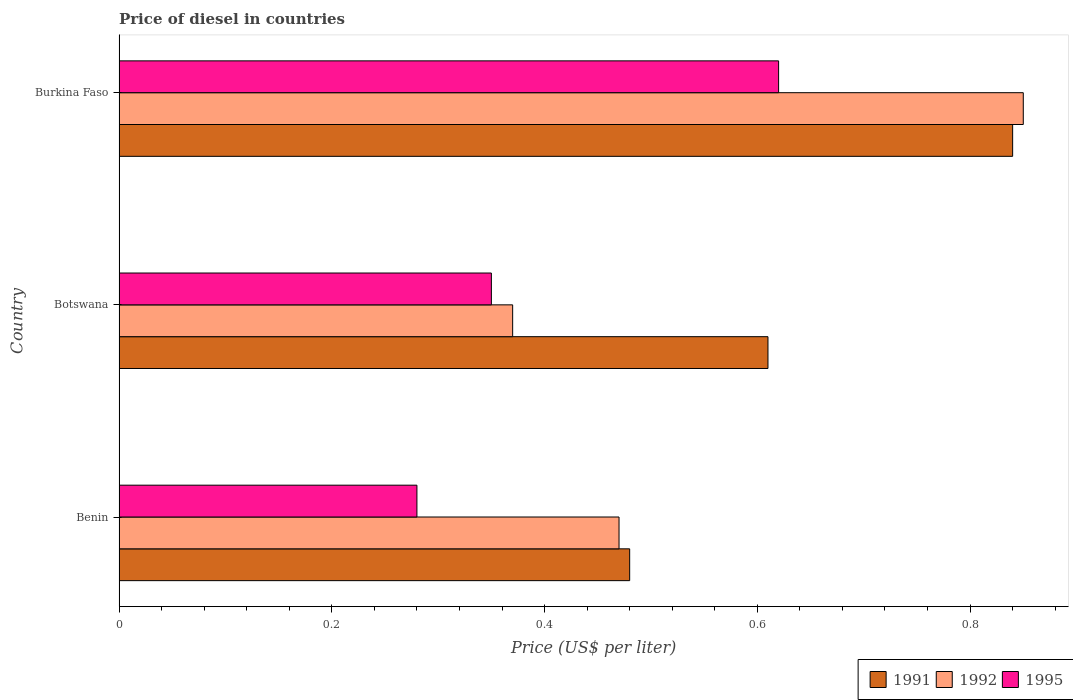How many different coloured bars are there?
Keep it short and to the point. 3. Are the number of bars per tick equal to the number of legend labels?
Offer a terse response. Yes. How many bars are there on the 2nd tick from the top?
Keep it short and to the point. 3. What is the label of the 1st group of bars from the top?
Offer a terse response. Burkina Faso. In how many cases, is the number of bars for a given country not equal to the number of legend labels?
Offer a very short reply. 0. What is the price of diesel in 1995 in Benin?
Provide a succinct answer. 0.28. Across all countries, what is the maximum price of diesel in 1991?
Your answer should be compact. 0.84. Across all countries, what is the minimum price of diesel in 1995?
Offer a very short reply. 0.28. In which country was the price of diesel in 1995 maximum?
Give a very brief answer. Burkina Faso. In which country was the price of diesel in 1995 minimum?
Make the answer very short. Benin. What is the total price of diesel in 1992 in the graph?
Provide a succinct answer. 1.69. What is the difference between the price of diesel in 1991 in Botswana and that in Burkina Faso?
Provide a succinct answer. -0.23. What is the difference between the price of diesel in 1995 in Benin and the price of diesel in 1992 in Botswana?
Provide a short and direct response. -0.09. What is the average price of diesel in 1992 per country?
Provide a short and direct response. 0.56. What is the difference between the price of diesel in 1992 and price of diesel in 1991 in Botswana?
Offer a terse response. -0.24. What is the ratio of the price of diesel in 1991 in Benin to that in Burkina Faso?
Keep it short and to the point. 0.57. What is the difference between the highest and the second highest price of diesel in 1995?
Ensure brevity in your answer.  0.27. What is the difference between the highest and the lowest price of diesel in 1995?
Provide a short and direct response. 0.34. In how many countries, is the price of diesel in 1995 greater than the average price of diesel in 1995 taken over all countries?
Make the answer very short. 1. Is the sum of the price of diesel in 1991 in Benin and Burkina Faso greater than the maximum price of diesel in 1995 across all countries?
Ensure brevity in your answer.  Yes. What does the 2nd bar from the top in Botswana represents?
Your response must be concise. 1992. Is it the case that in every country, the sum of the price of diesel in 1992 and price of diesel in 1991 is greater than the price of diesel in 1995?
Make the answer very short. Yes. What is the difference between two consecutive major ticks on the X-axis?
Your response must be concise. 0.2. How many legend labels are there?
Your answer should be very brief. 3. What is the title of the graph?
Offer a very short reply. Price of diesel in countries. What is the label or title of the X-axis?
Offer a terse response. Price (US$ per liter). What is the label or title of the Y-axis?
Ensure brevity in your answer.  Country. What is the Price (US$ per liter) of 1991 in Benin?
Ensure brevity in your answer.  0.48. What is the Price (US$ per liter) in 1992 in Benin?
Your answer should be compact. 0.47. What is the Price (US$ per liter) in 1995 in Benin?
Give a very brief answer. 0.28. What is the Price (US$ per liter) in 1991 in Botswana?
Provide a succinct answer. 0.61. What is the Price (US$ per liter) of 1992 in Botswana?
Keep it short and to the point. 0.37. What is the Price (US$ per liter) in 1991 in Burkina Faso?
Your answer should be compact. 0.84. What is the Price (US$ per liter) of 1995 in Burkina Faso?
Your answer should be compact. 0.62. Across all countries, what is the maximum Price (US$ per liter) in 1991?
Ensure brevity in your answer.  0.84. Across all countries, what is the maximum Price (US$ per liter) in 1992?
Your answer should be compact. 0.85. Across all countries, what is the maximum Price (US$ per liter) in 1995?
Make the answer very short. 0.62. Across all countries, what is the minimum Price (US$ per liter) of 1991?
Your response must be concise. 0.48. Across all countries, what is the minimum Price (US$ per liter) of 1992?
Make the answer very short. 0.37. Across all countries, what is the minimum Price (US$ per liter) in 1995?
Give a very brief answer. 0.28. What is the total Price (US$ per liter) of 1991 in the graph?
Ensure brevity in your answer.  1.93. What is the total Price (US$ per liter) of 1992 in the graph?
Give a very brief answer. 1.69. What is the difference between the Price (US$ per liter) of 1991 in Benin and that in Botswana?
Your response must be concise. -0.13. What is the difference between the Price (US$ per liter) of 1992 in Benin and that in Botswana?
Your answer should be very brief. 0.1. What is the difference between the Price (US$ per liter) in 1995 in Benin and that in Botswana?
Give a very brief answer. -0.07. What is the difference between the Price (US$ per liter) in 1991 in Benin and that in Burkina Faso?
Make the answer very short. -0.36. What is the difference between the Price (US$ per liter) of 1992 in Benin and that in Burkina Faso?
Provide a short and direct response. -0.38. What is the difference between the Price (US$ per liter) of 1995 in Benin and that in Burkina Faso?
Your answer should be very brief. -0.34. What is the difference between the Price (US$ per liter) of 1991 in Botswana and that in Burkina Faso?
Give a very brief answer. -0.23. What is the difference between the Price (US$ per liter) of 1992 in Botswana and that in Burkina Faso?
Offer a terse response. -0.48. What is the difference between the Price (US$ per liter) of 1995 in Botswana and that in Burkina Faso?
Your answer should be compact. -0.27. What is the difference between the Price (US$ per liter) of 1991 in Benin and the Price (US$ per liter) of 1992 in Botswana?
Offer a very short reply. 0.11. What is the difference between the Price (US$ per liter) in 1991 in Benin and the Price (US$ per liter) in 1995 in Botswana?
Keep it short and to the point. 0.13. What is the difference between the Price (US$ per liter) of 1992 in Benin and the Price (US$ per liter) of 1995 in Botswana?
Keep it short and to the point. 0.12. What is the difference between the Price (US$ per liter) in 1991 in Benin and the Price (US$ per liter) in 1992 in Burkina Faso?
Your answer should be very brief. -0.37. What is the difference between the Price (US$ per liter) of 1991 in Benin and the Price (US$ per liter) of 1995 in Burkina Faso?
Make the answer very short. -0.14. What is the difference between the Price (US$ per liter) of 1992 in Benin and the Price (US$ per liter) of 1995 in Burkina Faso?
Offer a very short reply. -0.15. What is the difference between the Price (US$ per liter) of 1991 in Botswana and the Price (US$ per liter) of 1992 in Burkina Faso?
Offer a terse response. -0.24. What is the difference between the Price (US$ per liter) of 1991 in Botswana and the Price (US$ per liter) of 1995 in Burkina Faso?
Provide a succinct answer. -0.01. What is the difference between the Price (US$ per liter) in 1992 in Botswana and the Price (US$ per liter) in 1995 in Burkina Faso?
Offer a terse response. -0.25. What is the average Price (US$ per liter) in 1991 per country?
Keep it short and to the point. 0.64. What is the average Price (US$ per liter) in 1992 per country?
Ensure brevity in your answer.  0.56. What is the average Price (US$ per liter) of 1995 per country?
Provide a short and direct response. 0.42. What is the difference between the Price (US$ per liter) of 1991 and Price (US$ per liter) of 1992 in Benin?
Provide a short and direct response. 0.01. What is the difference between the Price (US$ per liter) in 1992 and Price (US$ per liter) in 1995 in Benin?
Offer a very short reply. 0.19. What is the difference between the Price (US$ per liter) of 1991 and Price (US$ per liter) of 1992 in Botswana?
Offer a very short reply. 0.24. What is the difference between the Price (US$ per liter) of 1991 and Price (US$ per liter) of 1995 in Botswana?
Your answer should be very brief. 0.26. What is the difference between the Price (US$ per liter) in 1991 and Price (US$ per liter) in 1992 in Burkina Faso?
Provide a succinct answer. -0.01. What is the difference between the Price (US$ per liter) in 1991 and Price (US$ per liter) in 1995 in Burkina Faso?
Give a very brief answer. 0.22. What is the difference between the Price (US$ per liter) in 1992 and Price (US$ per liter) in 1995 in Burkina Faso?
Offer a very short reply. 0.23. What is the ratio of the Price (US$ per liter) in 1991 in Benin to that in Botswana?
Offer a terse response. 0.79. What is the ratio of the Price (US$ per liter) of 1992 in Benin to that in Botswana?
Keep it short and to the point. 1.27. What is the ratio of the Price (US$ per liter) of 1992 in Benin to that in Burkina Faso?
Offer a terse response. 0.55. What is the ratio of the Price (US$ per liter) in 1995 in Benin to that in Burkina Faso?
Keep it short and to the point. 0.45. What is the ratio of the Price (US$ per liter) in 1991 in Botswana to that in Burkina Faso?
Your answer should be very brief. 0.73. What is the ratio of the Price (US$ per liter) in 1992 in Botswana to that in Burkina Faso?
Make the answer very short. 0.44. What is the ratio of the Price (US$ per liter) of 1995 in Botswana to that in Burkina Faso?
Your response must be concise. 0.56. What is the difference between the highest and the second highest Price (US$ per liter) in 1991?
Your response must be concise. 0.23. What is the difference between the highest and the second highest Price (US$ per liter) of 1992?
Ensure brevity in your answer.  0.38. What is the difference between the highest and the second highest Price (US$ per liter) in 1995?
Your response must be concise. 0.27. What is the difference between the highest and the lowest Price (US$ per liter) of 1991?
Your answer should be compact. 0.36. What is the difference between the highest and the lowest Price (US$ per liter) of 1992?
Ensure brevity in your answer.  0.48. What is the difference between the highest and the lowest Price (US$ per liter) of 1995?
Your answer should be compact. 0.34. 